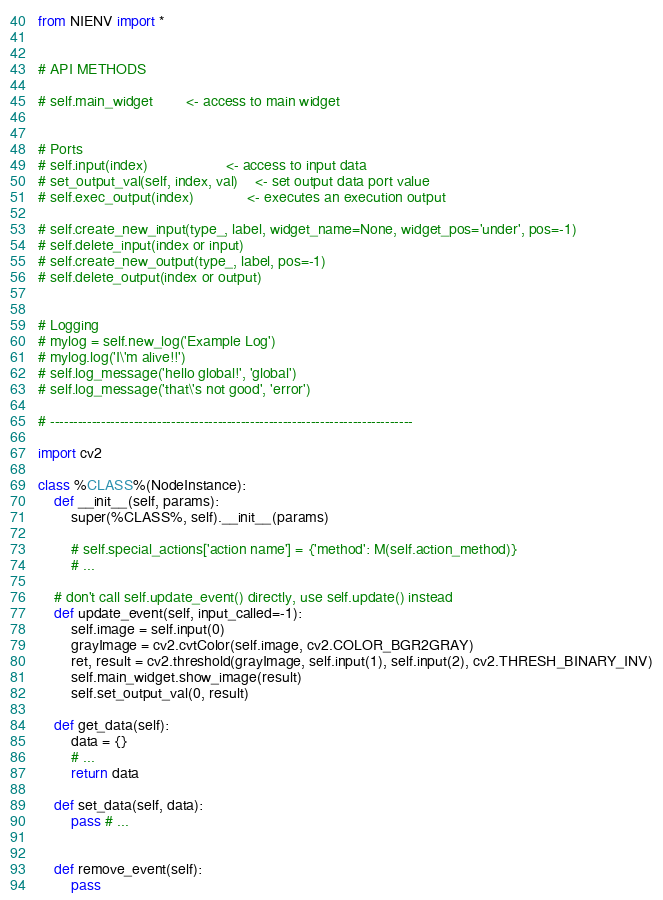Convert code to text. <code><loc_0><loc_0><loc_500><loc_500><_Python_>from NIENV import *


# API METHODS

# self.main_widget        <- access to main widget


# Ports
# self.input(index)                   <- access to input data
# set_output_val(self, index, val)    <- set output data port value
# self.exec_output(index)             <- executes an execution output

# self.create_new_input(type_, label, widget_name=None, widget_pos='under', pos=-1)
# self.delete_input(index or input)
# self.create_new_output(type_, label, pos=-1)
# self.delete_output(index or output)


# Logging
# mylog = self.new_log('Example Log')
# mylog.log('I\'m alive!!')
# self.log_message('hello global!', 'global')
# self.log_message('that\'s not good', 'error')

# ------------------------------------------------------------------------------

import cv2

class %CLASS%(NodeInstance):
    def __init__(self, params):
        super(%CLASS%, self).__init__(params)

        # self.special_actions['action name'] = {'method': M(self.action_method)}
        # ...

    # don't call self.update_event() directly, use self.update() instead
    def update_event(self, input_called=-1):
        self.image = self.input(0)
        grayImage = cv2.cvtColor(self.image, cv2.COLOR_BGR2GRAY)
        ret, result = cv2.threshold(grayImage, self.input(1), self.input(2), cv2.THRESH_BINARY_INV)
        self.main_widget.show_image(result)
        self.set_output_val(0, result)

    def get_data(self):
        data = {}
        # ...
        return data

    def set_data(self, data):
        pass # ...


    def remove_event(self):
        pass
</code> 